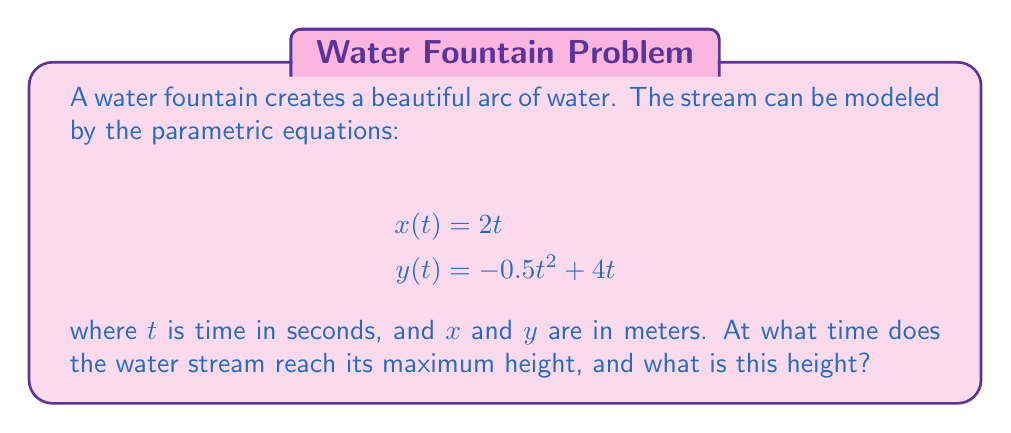Could you help me with this problem? To solve this problem, we'll follow these steps:

1) The maximum height occurs when the y-coordinate is at its highest point. This happens when the vertical velocity is zero.

2) To find the vertical velocity, we need to differentiate $y(t)$ with respect to $t$:

   $$\frac{dy}{dt} = -t + 4$$

3) Set this equal to zero to find when the vertical velocity is zero:

   $$-t + 4 = 0$$
   $$t = 4$$

4) This means the water reaches its maximum height at $t = 4$ seconds.

5) To find the maximum height, we substitute $t = 4$ into the equation for $y(t)$:

   $$y(4) = -0.5(4)^2 + 4(4)$$
   $$= -0.5(16) + 16$$
   $$= -8 + 16$$
   $$= 8$$

Therefore, the maximum height is 8 meters.

[asy]
size(200,200);
real f(real x) {return -0.5*x^2/4 + x;}
draw(graph(f,0,8), blue);
dot((4,8), red);
label("(4, 8)", (4,8), N);
xaxis(Label("$x$ (m)"), Arrow);
yaxis(Label("$y$ (m)"), Arrow);
[/asy]
Answer: The water stream reaches its maximum height at $t = 4$ seconds, and the maximum height is 8 meters. 